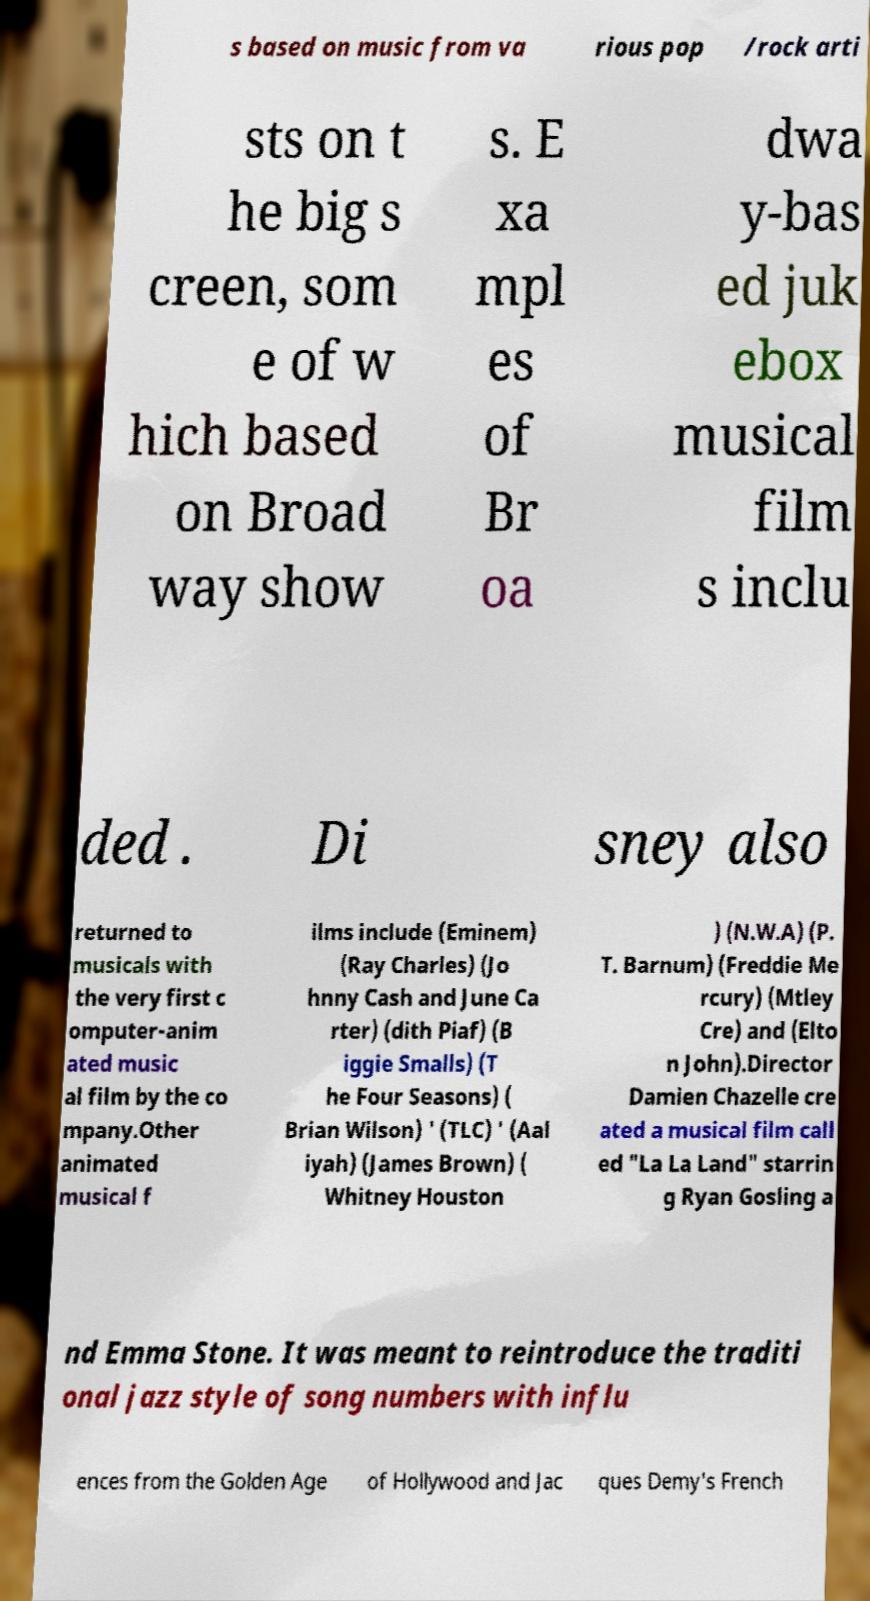Could you extract and type out the text from this image? s based on music from va rious pop /rock arti sts on t he big s creen, som e of w hich based on Broad way show s. E xa mpl es of Br oa dwa y-bas ed juk ebox musical film s inclu ded . Di sney also returned to musicals with the very first c omputer-anim ated music al film by the co mpany.Other animated musical f ilms include (Eminem) (Ray Charles) (Jo hnny Cash and June Ca rter) (dith Piaf) (B iggie Smalls) (T he Four Seasons) ( Brian Wilson) ' (TLC) ' (Aal iyah) (James Brown) ( Whitney Houston ) (N.W.A) (P. T. Barnum) (Freddie Me rcury) (Mtley Cre) and (Elto n John).Director Damien Chazelle cre ated a musical film call ed "La La Land" starrin g Ryan Gosling a nd Emma Stone. It was meant to reintroduce the traditi onal jazz style of song numbers with influ ences from the Golden Age of Hollywood and Jac ques Demy's French 